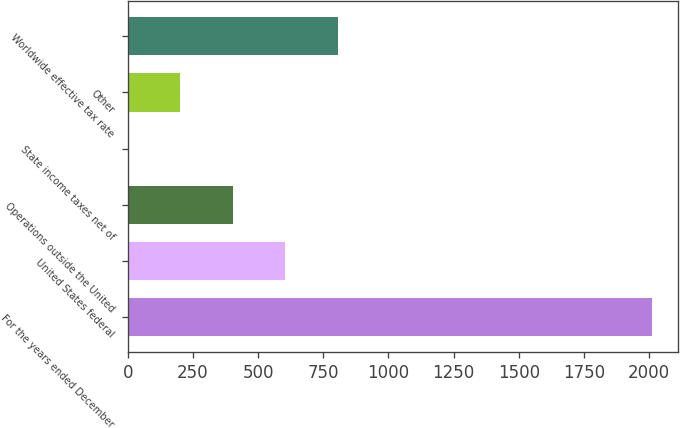Convert chart. <chart><loc_0><loc_0><loc_500><loc_500><bar_chart><fcel>For the years ended December<fcel>United States federal<fcel>Operations outside the United<fcel>State income taxes net of<fcel>Other<fcel>Worldwide effective tax rate<nl><fcel>2011<fcel>604<fcel>403<fcel>1<fcel>202<fcel>805<nl></chart> 